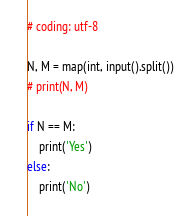<code> <loc_0><loc_0><loc_500><loc_500><_Python_># coding: utf-8

N, M = map(int, input().split())
# print(N, M)

if N == M:
    print('Yes')
else:
    print('No')</code> 